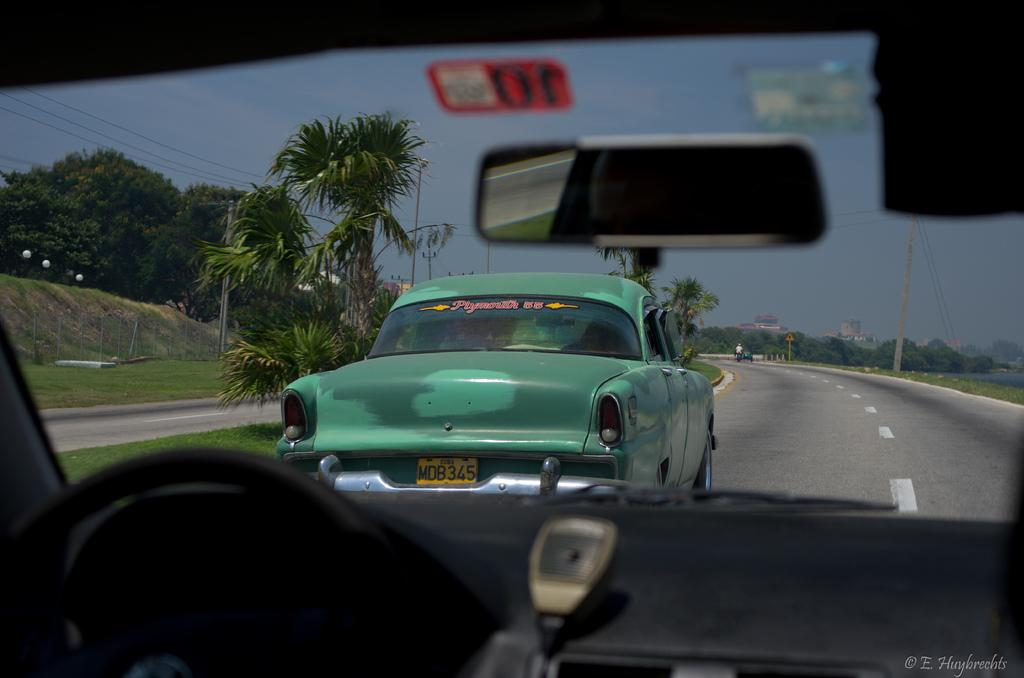What can be seen on the road in the image? There are vehicles on the road in the image. What is present alongside the road in the image? There are poles on both sides of the road in the image. What type of natural elements can be seen in the image? There are many trees visible in the image. What can be seen in the distance in the image? There are buildings in the background of the image, and the sky is visible in the background of the image. What type of haircut is the tree on the left side of the image getting? There is no haircut being given in the image, as it features vehicles on the road, poles, trees, buildings, and the sky. What sense is being stimulated by the weight of the buildings in the image? The image does not mention any weight associated with the buildings, nor does it suggest that any senses are being stimulated. 